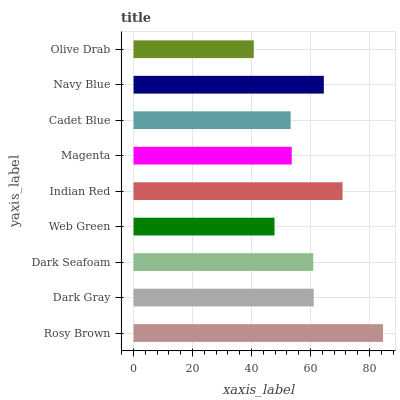Is Olive Drab the minimum?
Answer yes or no. Yes. Is Rosy Brown the maximum?
Answer yes or no. Yes. Is Dark Gray the minimum?
Answer yes or no. No. Is Dark Gray the maximum?
Answer yes or no. No. Is Rosy Brown greater than Dark Gray?
Answer yes or no. Yes. Is Dark Gray less than Rosy Brown?
Answer yes or no. Yes. Is Dark Gray greater than Rosy Brown?
Answer yes or no. No. Is Rosy Brown less than Dark Gray?
Answer yes or no. No. Is Dark Seafoam the high median?
Answer yes or no. Yes. Is Dark Seafoam the low median?
Answer yes or no. Yes. Is Web Green the high median?
Answer yes or no. No. Is Dark Gray the low median?
Answer yes or no. No. 